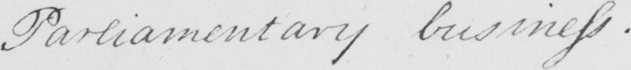What is written in this line of handwriting? Parliamentary business . 